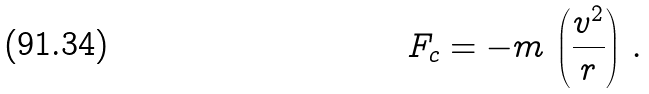Convert formula to latex. <formula><loc_0><loc_0><loc_500><loc_500>F _ { c } = - m \, \left ( \frac { v ^ { 2 } } { r } \right ) \, .</formula> 